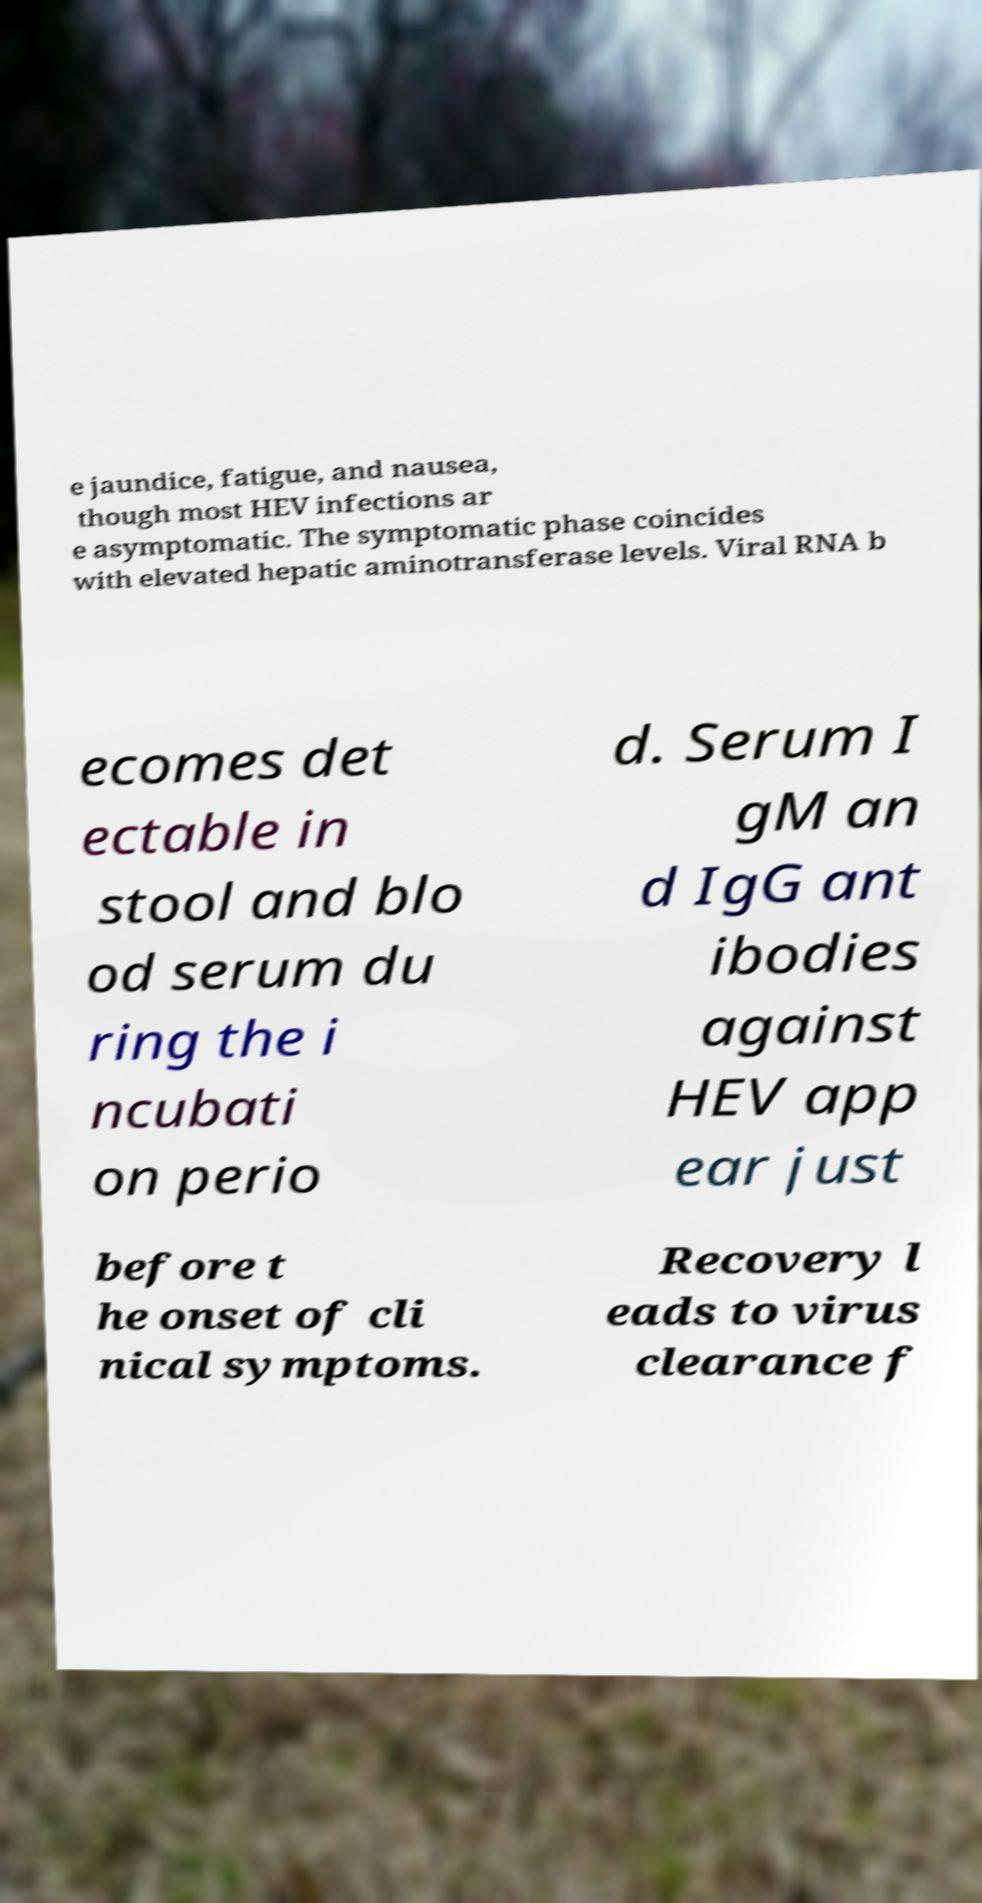Can you read and provide the text displayed in the image?This photo seems to have some interesting text. Can you extract and type it out for me? e jaundice, fatigue, and nausea, though most HEV infections ar e asymptomatic. The symptomatic phase coincides with elevated hepatic aminotransferase levels. Viral RNA b ecomes det ectable in stool and blo od serum du ring the i ncubati on perio d. Serum I gM an d IgG ant ibodies against HEV app ear just before t he onset of cli nical symptoms. Recovery l eads to virus clearance f 